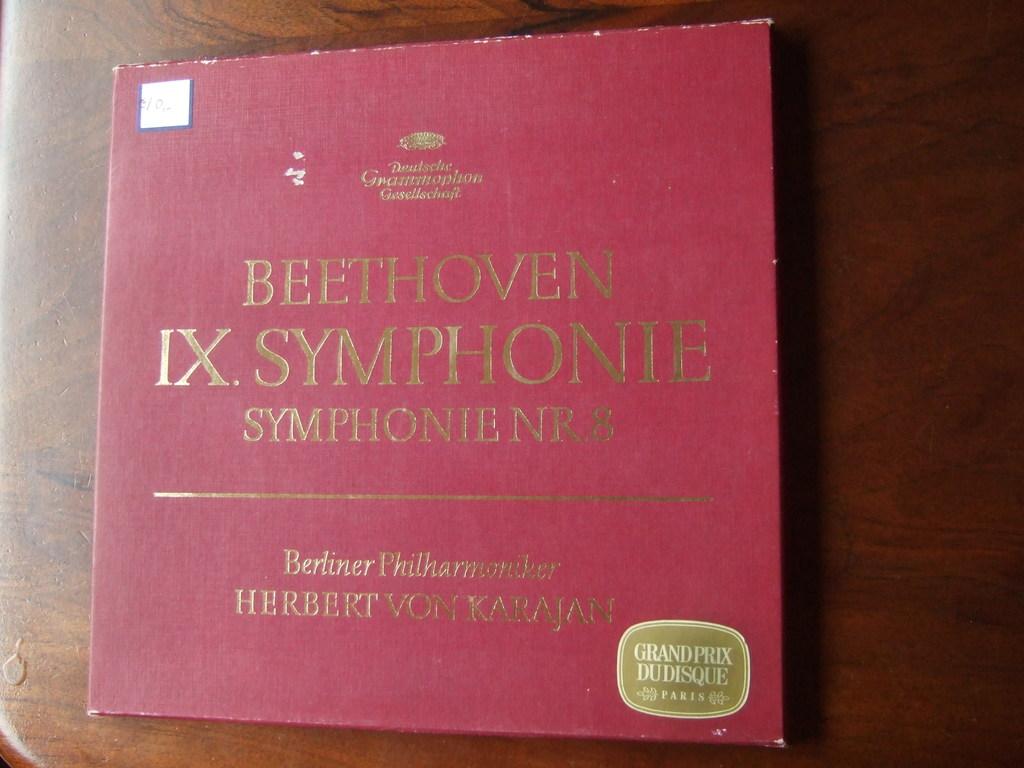What symphony of beethoven's is this?
Make the answer very short. Ix. What does the gold sticker say?
Offer a terse response. Grand prix dudisque. 